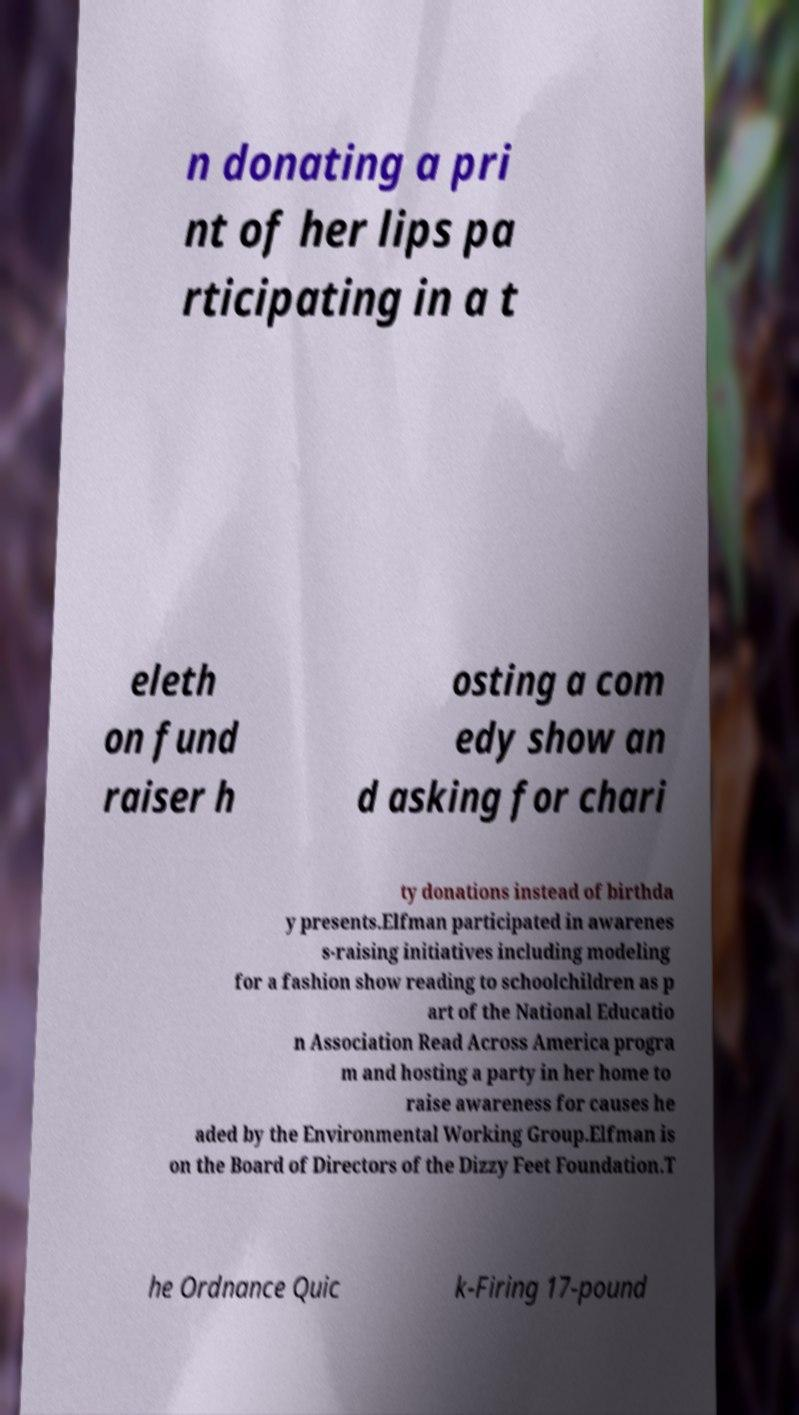Could you extract and type out the text from this image? n donating a pri nt of her lips pa rticipating in a t eleth on fund raiser h osting a com edy show an d asking for chari ty donations instead of birthda y presents.Elfman participated in awarenes s-raising initiatives including modeling for a fashion show reading to schoolchildren as p art of the National Educatio n Association Read Across America progra m and hosting a party in her home to raise awareness for causes he aded by the Environmental Working Group.Elfman is on the Board of Directors of the Dizzy Feet Foundation.T he Ordnance Quic k-Firing 17-pound 